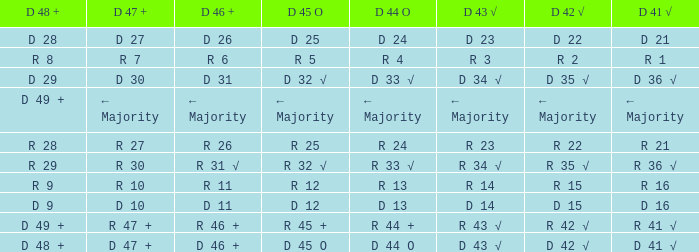What is the value of D 43 √ when the value of D 42 √ is d 42 √? D 43 √. Can you parse all the data within this table? {'header': ['D 48 +', 'D 47 +', 'D 46 +', 'D 45 O', 'D 44 O', 'D 43 √', 'D 42 √', 'D 41 √'], 'rows': [['D 28', 'D 27', 'D 26', 'D 25', 'D 24', 'D 23', 'D 22', 'D 21'], ['R 8', 'R 7', 'R 6', 'R 5', 'R 4', 'R 3', 'R 2', 'R 1'], ['D 29', 'D 30', 'D 31', 'D 32 √', 'D 33 √', 'D 34 √', 'D 35 √', 'D 36 √'], ['D 49 +', '← Majority', '← Majority', '← Majority', '← Majority', '← Majority', '← Majority', '← Majority'], ['R 28', 'R 27', 'R 26', 'R 25', 'R 24', 'R 23', 'R 22', 'R 21'], ['R 29', 'R 30', 'R 31 √', 'R 32 √', 'R 33 √', 'R 34 √', 'R 35 √', 'R 36 √'], ['R 9', 'R 10', 'R 11', 'R 12', 'R 13', 'R 14', 'R 15', 'R 16'], ['D 9', 'D 10', 'D 11', 'D 12', 'D 13', 'D 14', 'D 15', 'D 16'], ['D 49 +', 'R 47 +', 'R 46 +', 'R 45 +', 'R 44 +', 'R 43 √', 'R 42 √', 'R 41 √'], ['D 48 +', 'D 47 +', 'D 46 +', 'D 45 O', 'D 44 O', 'D 43 √', 'D 42 √', 'D 41 √']]} 